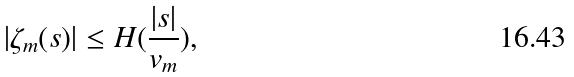Convert formula to latex. <formula><loc_0><loc_0><loc_500><loc_500>| \zeta _ { m } ( s ) | \leq H ( \frac { | s | } { v _ { m } } ) ,</formula> 